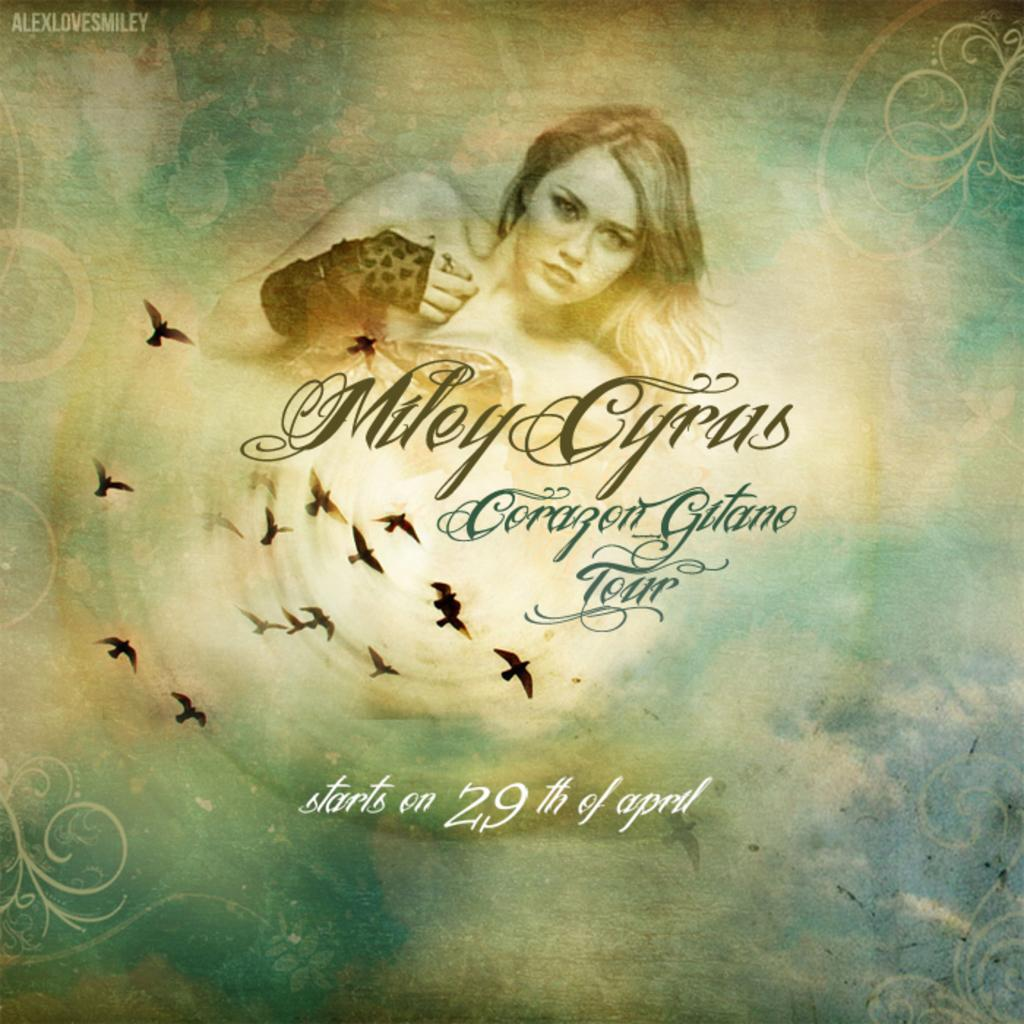Provide a one-sentence caption for the provided image. A poster of Miley Cyrus with her name Miley Cyrus below the picture of her.. 